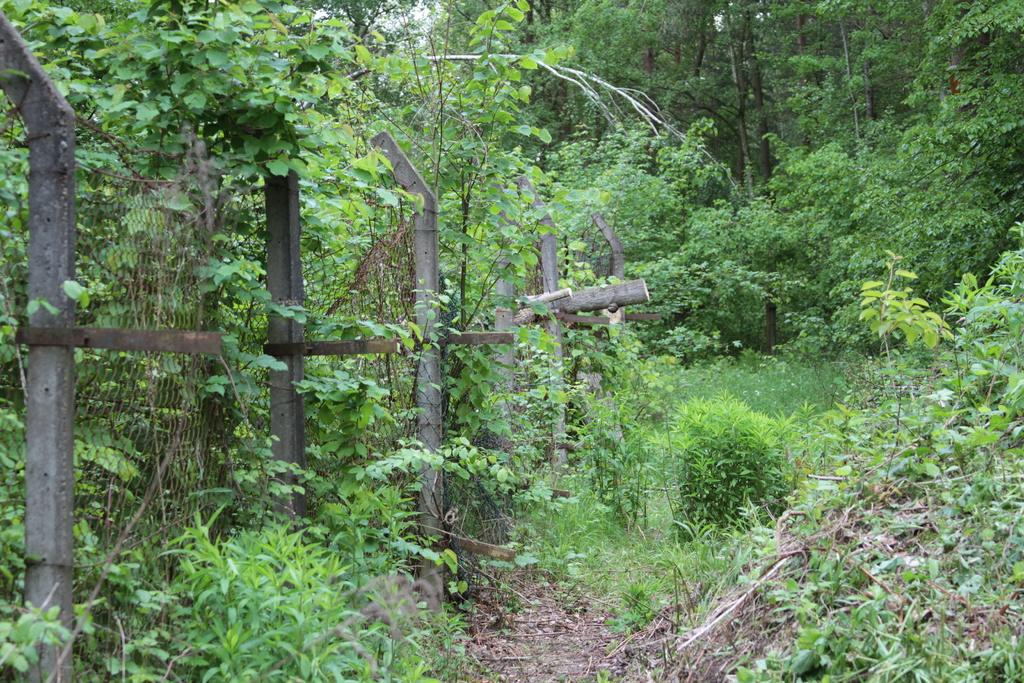What type of vegetation is visible on the ground in the image? There are many plants and trees on the ground in the image. Can you describe any man-made structures in the image? Yes, there is a net fencing on the left side of the image. What type of teeth can be seen on the leaves of the plants in the image? There are no teeth visible on the leaves of the plants in the image, as leaves do not have teeth. 